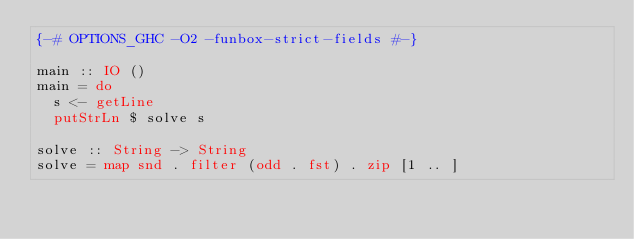Convert code to text. <code><loc_0><loc_0><loc_500><loc_500><_Haskell_>{-# OPTIONS_GHC -O2 -funbox-strict-fields #-}

main :: IO ()
main = do
  s <- getLine
  putStrLn $ solve s

solve :: String -> String
solve = map snd . filter (odd . fst) . zip [1 .. ]
</code> 